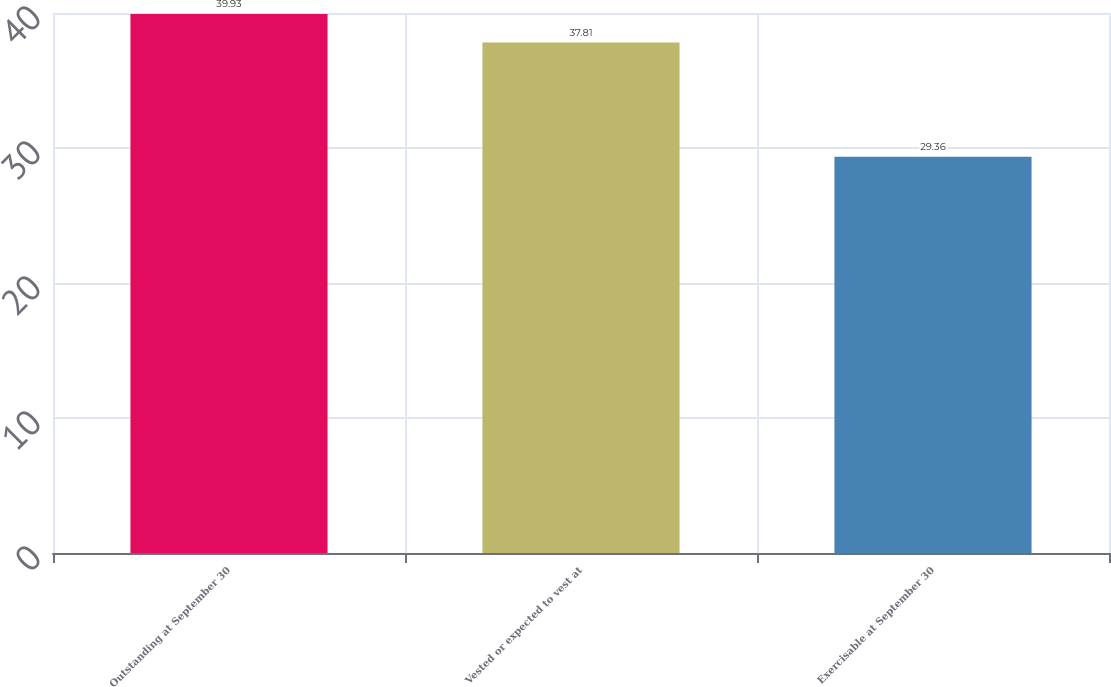<chart> <loc_0><loc_0><loc_500><loc_500><bar_chart><fcel>Outstanding at September 30<fcel>Vested or expected to vest at<fcel>Exercisable at September 30<nl><fcel>39.93<fcel>37.81<fcel>29.36<nl></chart> 